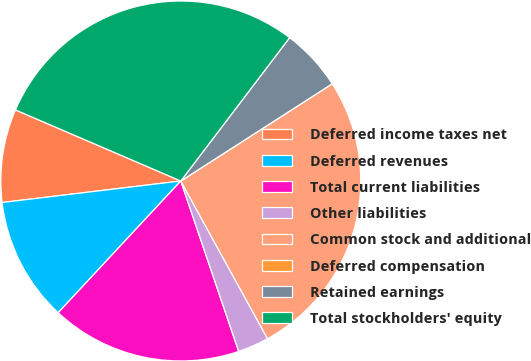Convert chart. <chart><loc_0><loc_0><loc_500><loc_500><pie_chart><fcel>Deferred income taxes net<fcel>Deferred revenues<fcel>Total current liabilities<fcel>Other liabilities<fcel>Common stock and additional<fcel>Deferred compensation<fcel>Retained earnings<fcel>Total stockholders' equity<nl><fcel>8.37%<fcel>11.16%<fcel>17.14%<fcel>2.79%<fcel>26.08%<fcel>0.0%<fcel>5.58%<fcel>28.87%<nl></chart> 